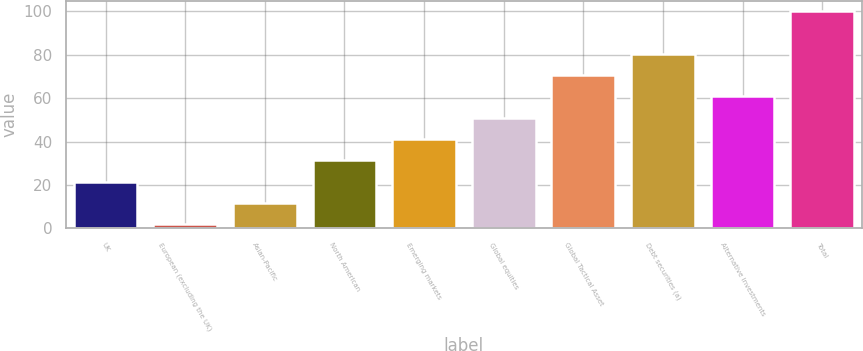<chart> <loc_0><loc_0><loc_500><loc_500><bar_chart><fcel>UK<fcel>European (excluding the UK)<fcel>Asian-Pacific<fcel>North American<fcel>Emerging markets<fcel>Global equities<fcel>Global Tactical Asset<fcel>Debt securities (a)<fcel>Alternative investments<fcel>Total<nl><fcel>21.6<fcel>2<fcel>11.8<fcel>31.4<fcel>41.2<fcel>51<fcel>70.6<fcel>80.4<fcel>60.8<fcel>100<nl></chart> 